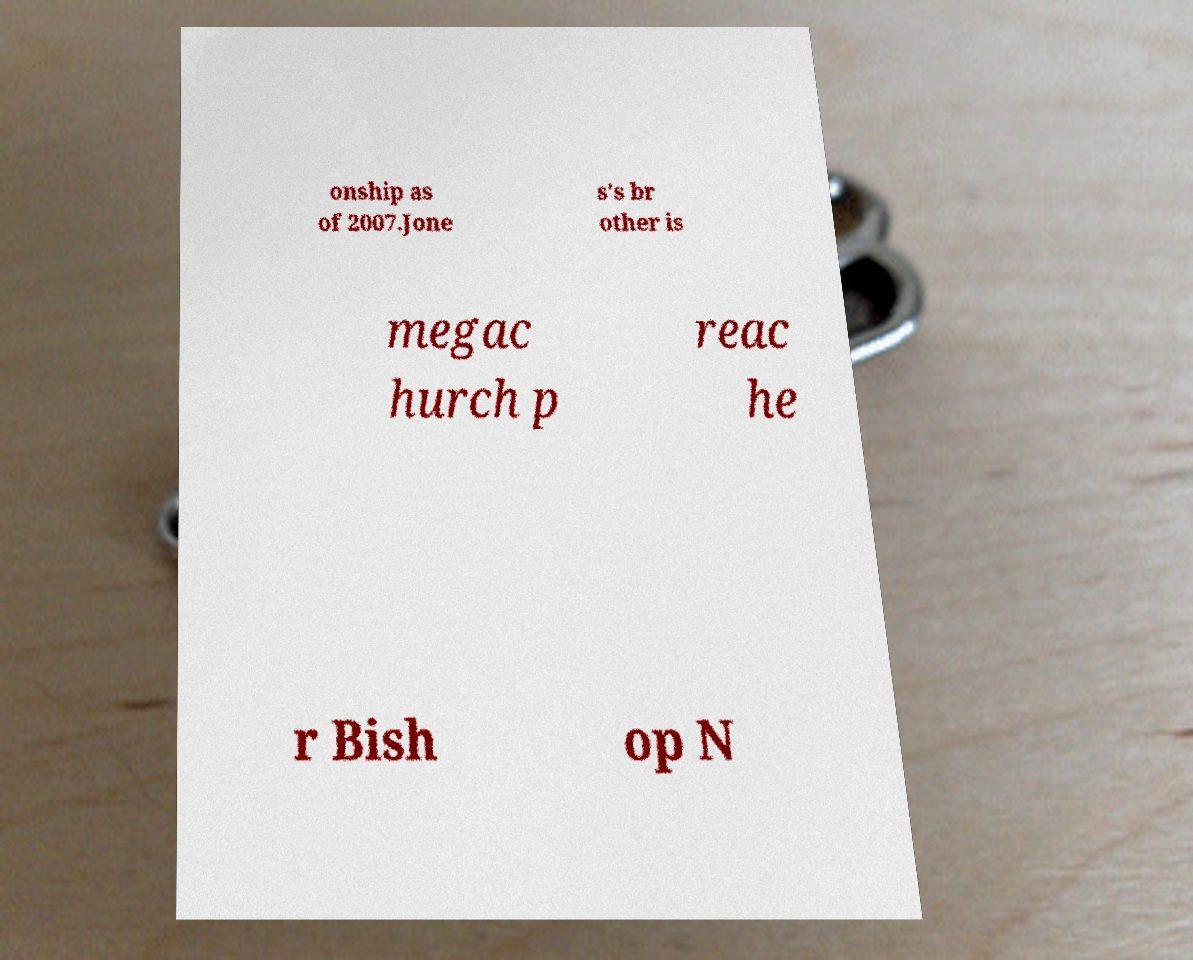I need the written content from this picture converted into text. Can you do that? onship as of 2007.Jone s's br other is megac hurch p reac he r Bish op N 